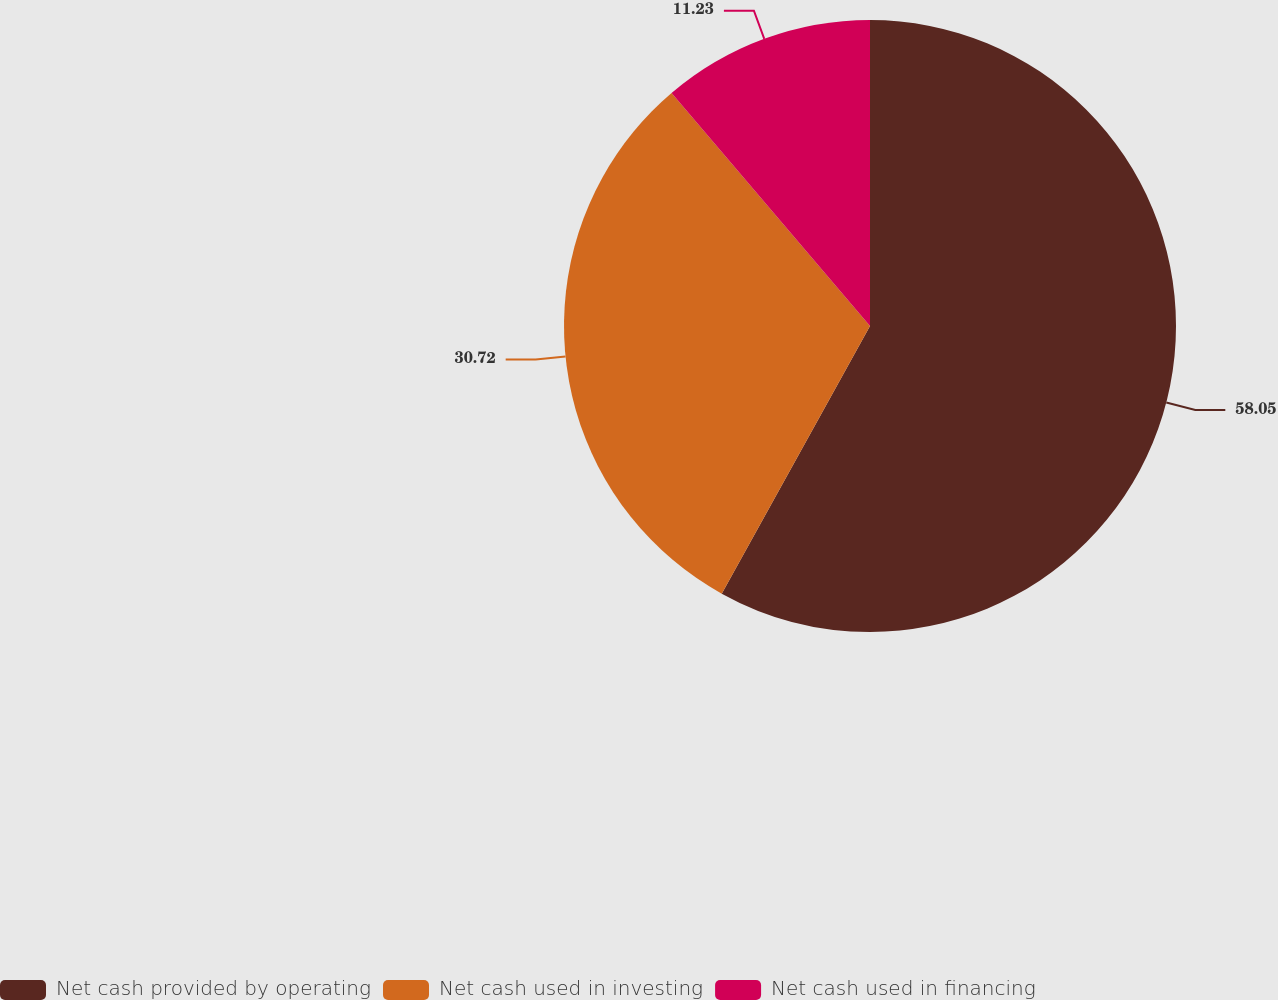<chart> <loc_0><loc_0><loc_500><loc_500><pie_chart><fcel>Net cash provided by operating<fcel>Net cash used in investing<fcel>Net cash used in financing<nl><fcel>58.05%<fcel>30.72%<fcel>11.23%<nl></chart> 